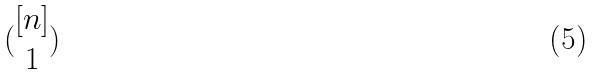Convert formula to latex. <formula><loc_0><loc_0><loc_500><loc_500>( \begin{matrix} [ n ] \\ 1 \end{matrix} )</formula> 